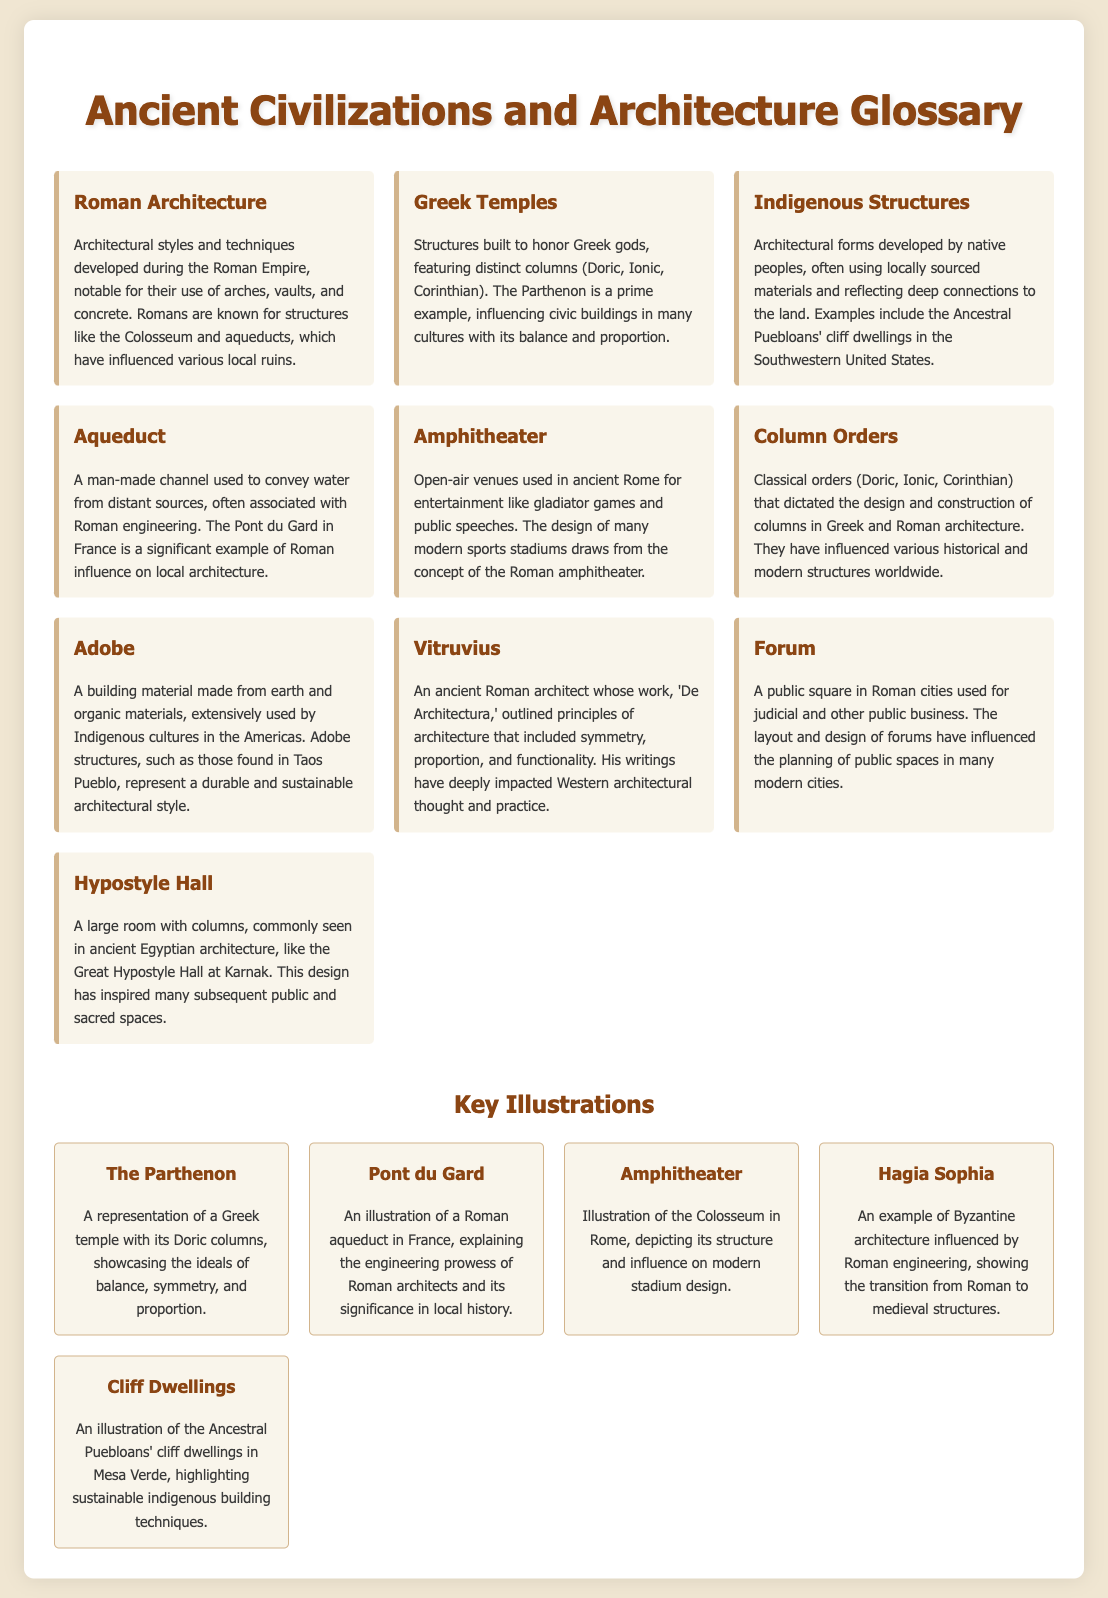What is Roman architecture known for? Roman architecture is notable for its use of arches, vaults, and concrete, as mentioned in the glossary.
Answer: arches, vaults, and concrete What is a prime example of Greek temples? The glossary states that the Parthenon is a prime example of Greek temples.
Answer: Parthenon What is the significance of aqueducts? Aqueducts are man-made channels associated with Roman engineering, conveying water from distant sources, as mentioned in the document.
Answer: conveying water Which indigenous group's architecture is mentioned? The document notes Indigenous Structures from native peoples, specifically referring to the Ancestral Puebloans.
Answer: Ancestral Puebloans What classical column orders are referred to? The glossary lists Doric, Ionic, and Corinthian as the classical orders in architecture.
Answer: Doric, Ionic, Corinthian Who was Vitruvius? Vitruvius is identified in the document as an ancient Roman architect whose work impacted architectural principles.
Answer: an ancient Roman architect What is an example of an amphitheater? The Colosseum is provided as an example of an amphitheater in the document.
Answer: Colosseum What style are adobe structures associated with? Adobe structures are extensively used by Indigenous cultures, reflecting a sustainable architectural style.
Answer: sustainable architectural style What public space design is influenced by Roman forums? The glossary states that the planning of public spaces in modern cities has been influenced by the design of forums.
Answer: public spaces in modern cities What does the illustration of the Great Hypostyle Hall represent? The Great Hypostyle Hall at Karnak is a large room with columns, representing ancient Egyptian architecture.
Answer: large room with columns 